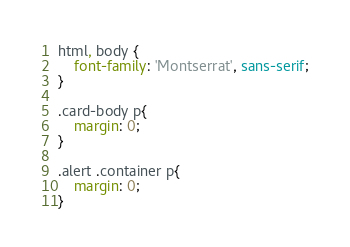<code> <loc_0><loc_0><loc_500><loc_500><_CSS_>html, body {
    font-family: 'Montserrat', sans-serif;
}

.card-body p{
    margin: 0;
}

.alert .container p{
    margin: 0;
}</code> 